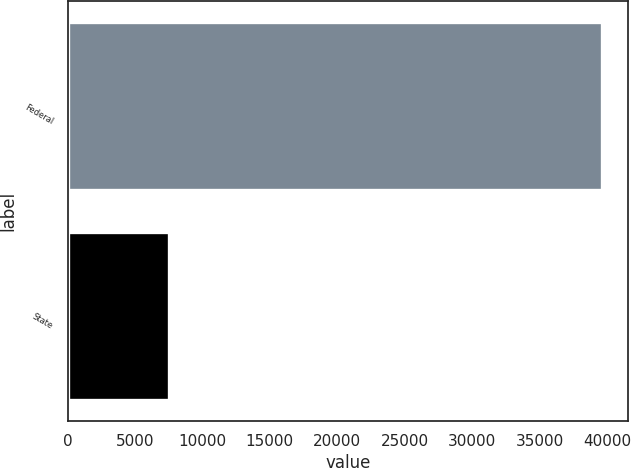Convert chart to OTSL. <chart><loc_0><loc_0><loc_500><loc_500><bar_chart><fcel>Federal<fcel>State<nl><fcel>39616<fcel>7527<nl></chart> 